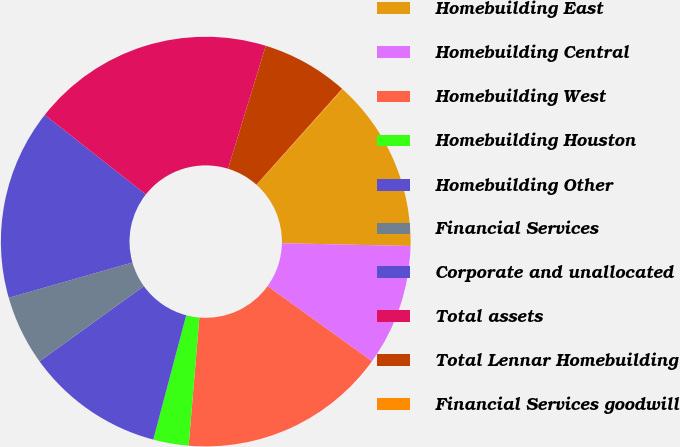<chart> <loc_0><loc_0><loc_500><loc_500><pie_chart><fcel>Homebuilding East<fcel>Homebuilding Central<fcel>Homebuilding West<fcel>Homebuilding Houston<fcel>Homebuilding Other<fcel>Financial Services<fcel>Corporate and unallocated<fcel>Total assets<fcel>Total Lennar Homebuilding<fcel>Financial Services goodwill<nl><fcel>13.68%<fcel>9.59%<fcel>16.4%<fcel>2.79%<fcel>10.95%<fcel>5.51%<fcel>15.04%<fcel>19.12%<fcel>6.87%<fcel>0.06%<nl></chart> 